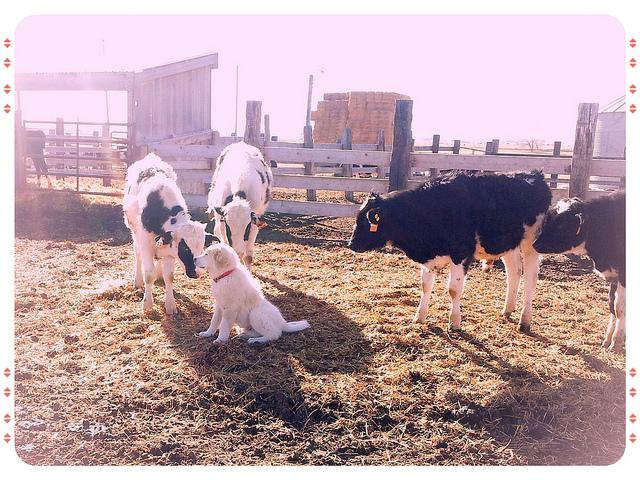What are the cows looking at?

Choices:
A) dog
B) rat
C) lion
D) cat dog 